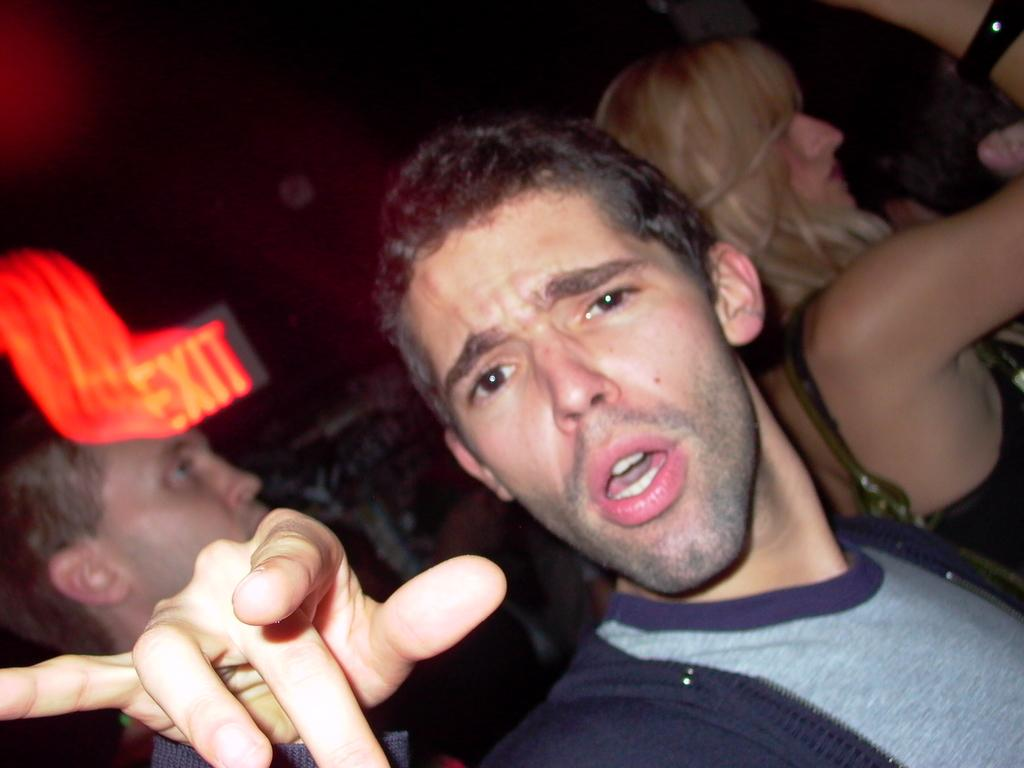How many people are present in the image? There are three people in the image. What can be observed about the background of the image? The background of the image is dark. What type of shoes is the woman wearing in the image? There is no woman present in the image, and therefore no shoes to describe. 